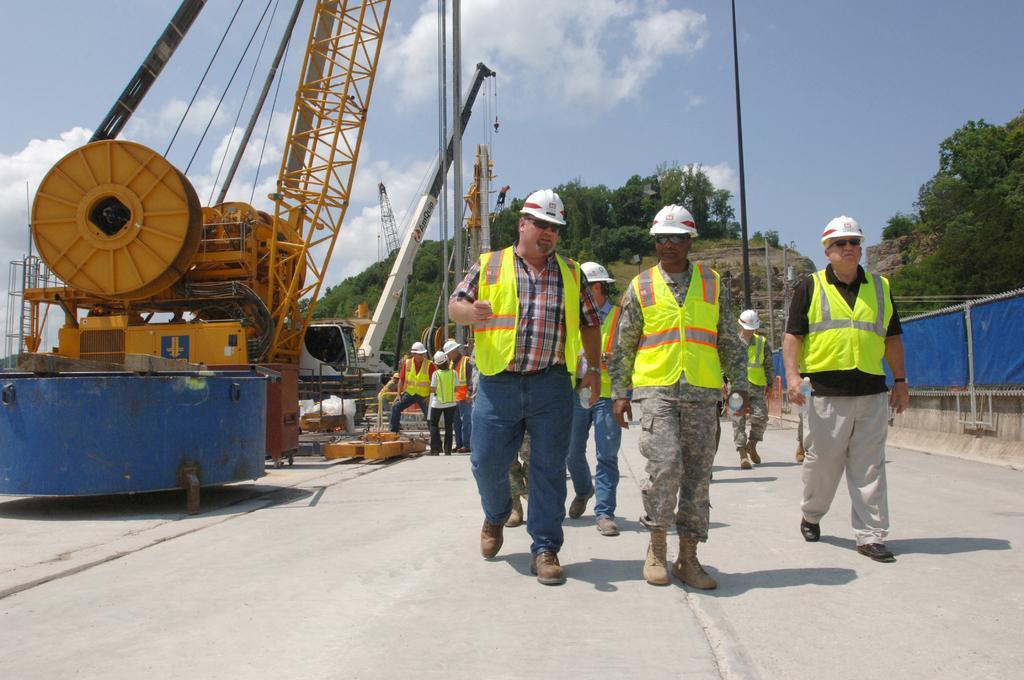Can you describe this image briefly? On the right side, there are persons in light green color jackets, walking on the road. In the background, there are persons, there is an excavator, a wheel, a fencing, there are trees on the mountains and there are clouds in the blue sky. 